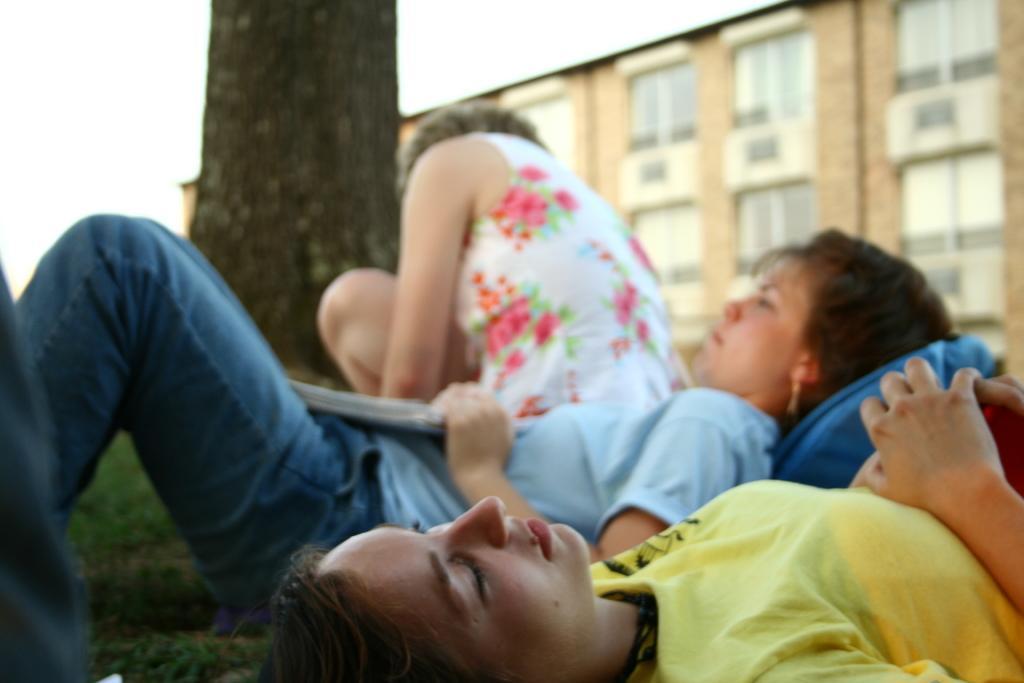Can you describe this image briefly? In this picture we can see there are two people laying on the path and a person is sitting and behind the people there is a tree trunk, building and a sky. 